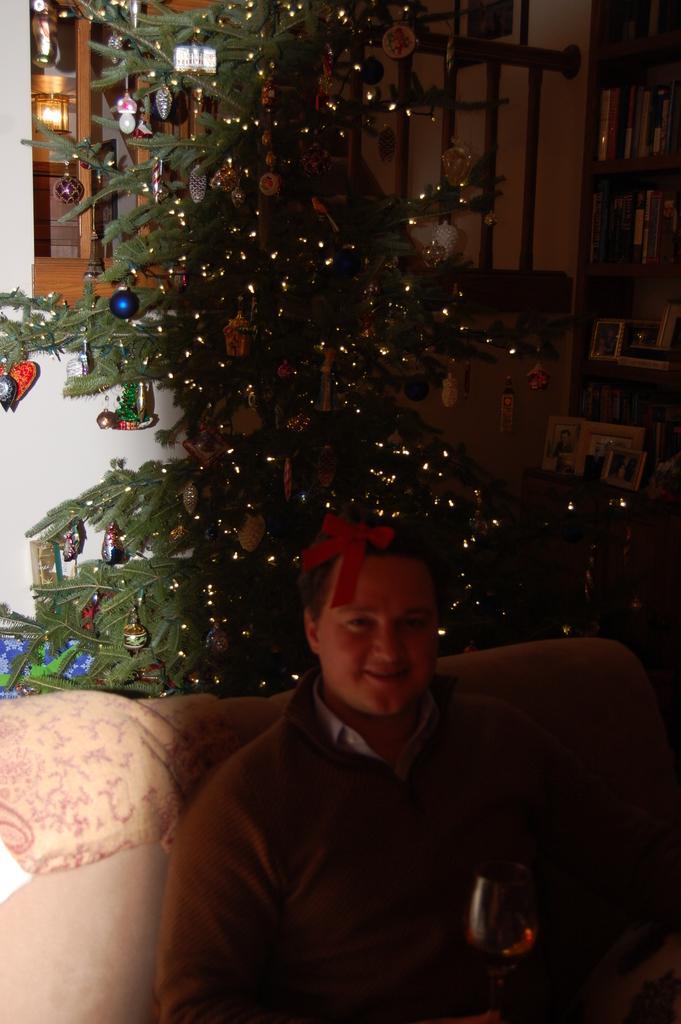Can you describe this image briefly? In this image, we can see a person holding a glass is sitting. We can see the sofa. We can see some Christmas trees. We can see some shelves with objects. We can see some objects in the background. We can see some wooden poles. 